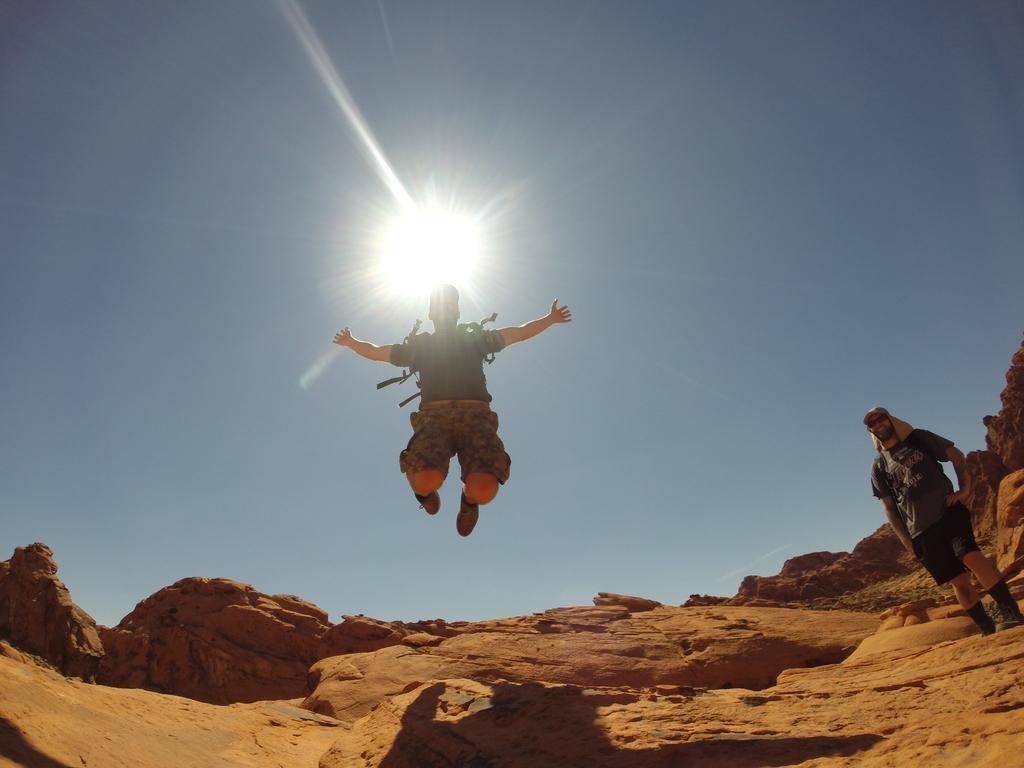Describe this image in one or two sentences. In the center of the image we can see person in the air. On the right side of the image we can see person standing on the ground. In the background we can see sky. 